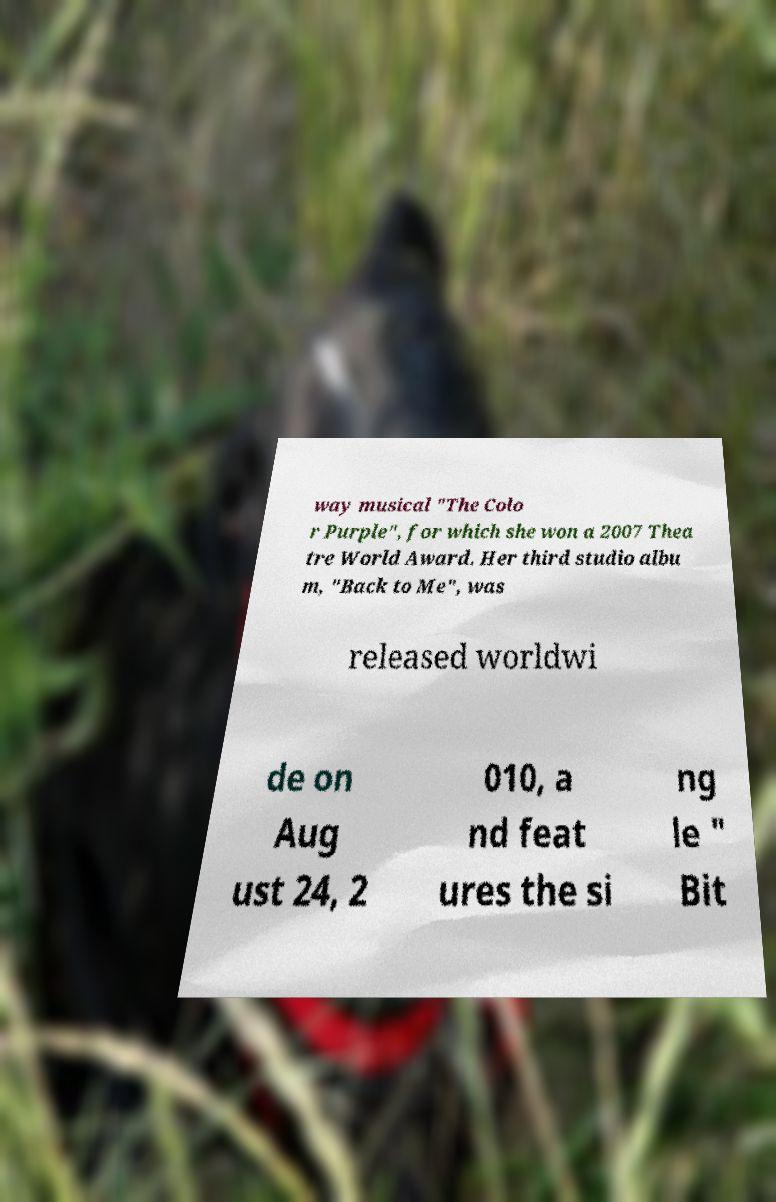Can you accurately transcribe the text from the provided image for me? way musical "The Colo r Purple", for which she won a 2007 Thea tre World Award. Her third studio albu m, "Back to Me", was released worldwi de on Aug ust 24, 2 010, a nd feat ures the si ng le " Bit 